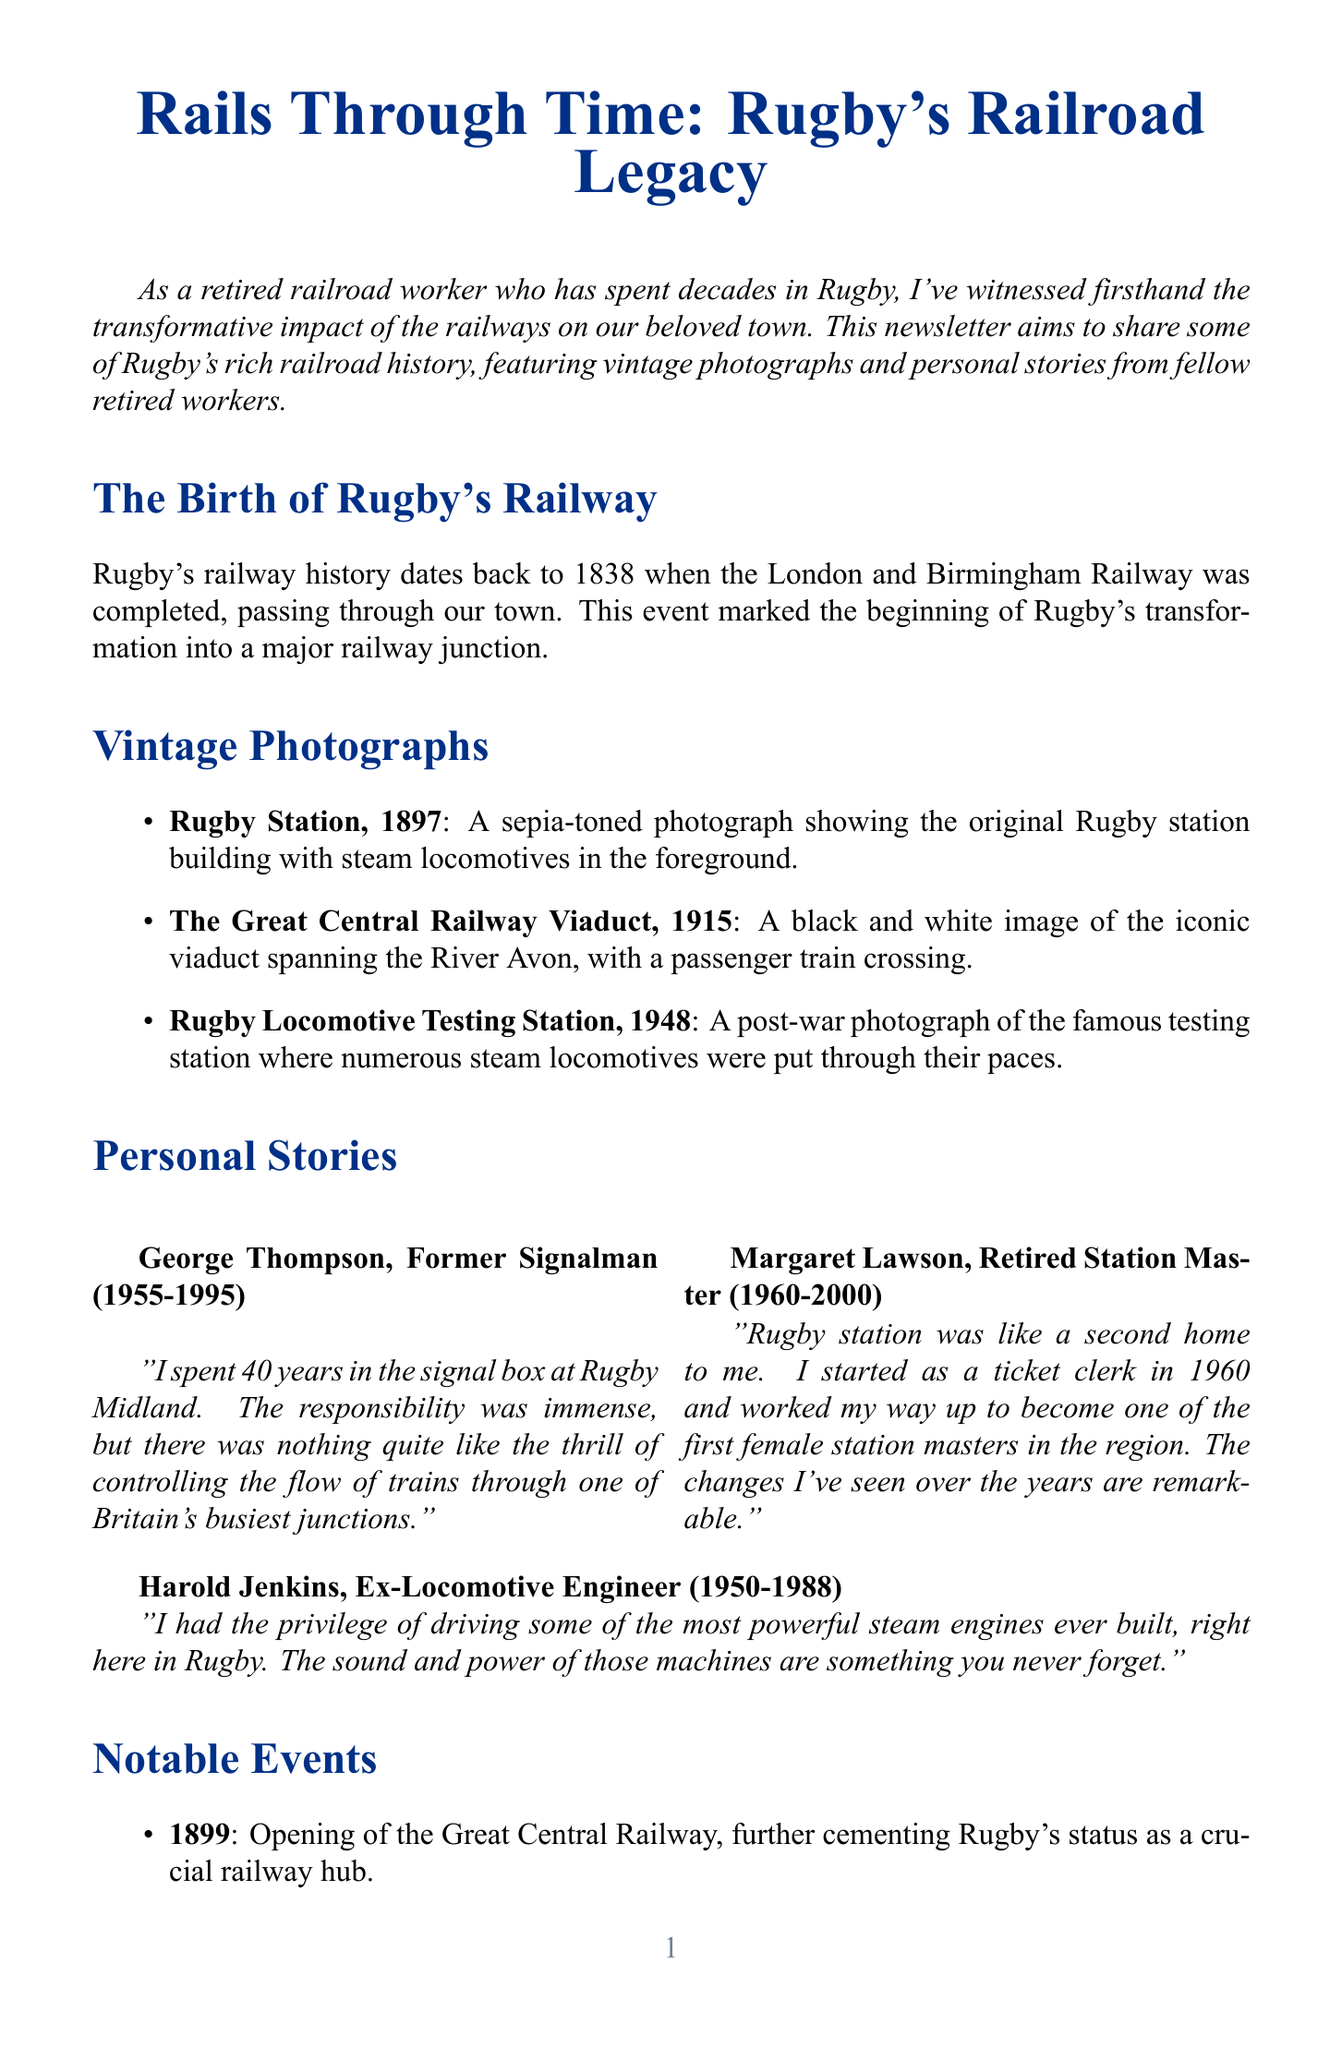what year was Rugby's railway history initiated? The document states that Rugby's railway history began in 1838 with the completion of the London and Birmingham Railway.
Answer: 1838 who was the first female station master in Rugby? Margaret Lawson mentions in her story that she became one of the first female station masters in the region.
Answer: Margaret Lawson what significant railway event occurred in 1948? The document lists the nationalization of the railways in 1948 as a notable event affecting Rugby.
Answer: Nationalization of the railways how many years did George Thompson serve as a signalman? George Thompson's quote indicates he served in the signal box from 1955 to 1995, which is 40 years.
Answer: 40 years which landmark opened in 1885? The document states that Rugby Station, which remains vital to the rail network, opened in 1885.
Answer: Rugby Station what photograph features a passenger train crossing a viaduct? The document describes a photograph titled "The Great Central Railway Viaduct, 1915" that depicts this scene.
Answer: The Great Central Railway Viaduct, 1915 what was a consequence of the Beeching cuts in 1965? The document notes that the closure of Rugby Central Station in 1965 marked the end of an era for the town's rail service.
Answer: Closure of Rugby Central Station who drove some of the most powerful steam engines in Rugby? Harold Jenkins shares that he had the privilege of driving powerful steam engines in Rugby.
Answer: Harold Jenkins 